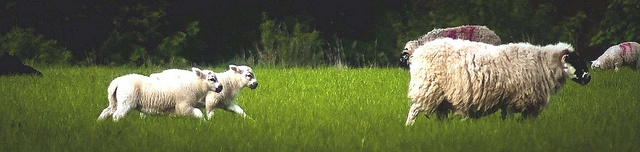Describe the objects in this image and their specific colors. I can see sheep in black, ivory, and tan tones, sheep in black, ivory, and tan tones, sheep in black, ivory, olive, gray, and beige tones, sheep in black, gray, and darkgray tones, and sheep in black, gray, darkgray, darkgreen, and lightgray tones in this image. 